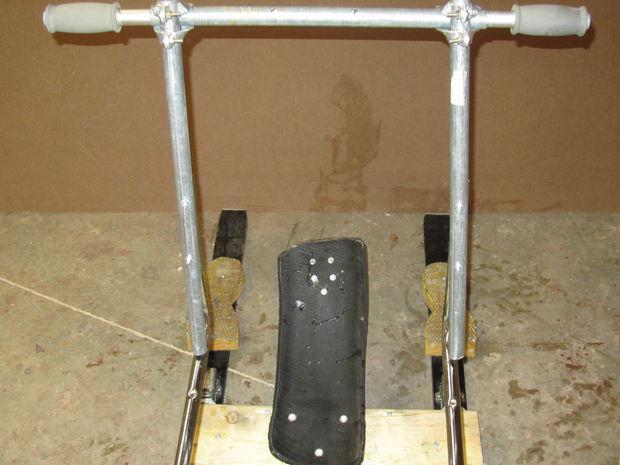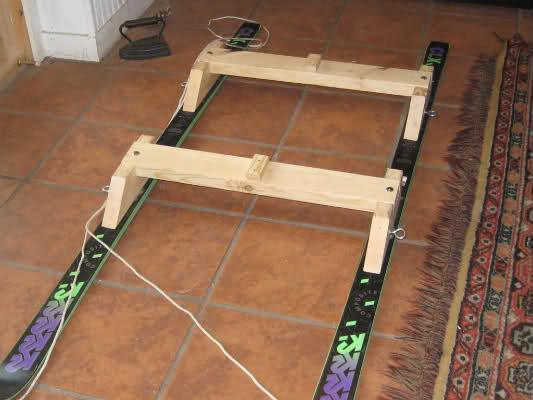The first image is the image on the left, the second image is the image on the right. Examine the images to the left and right. Is the description "There is at least one person pictured with a sled like object." accurate? Answer yes or no. No. 